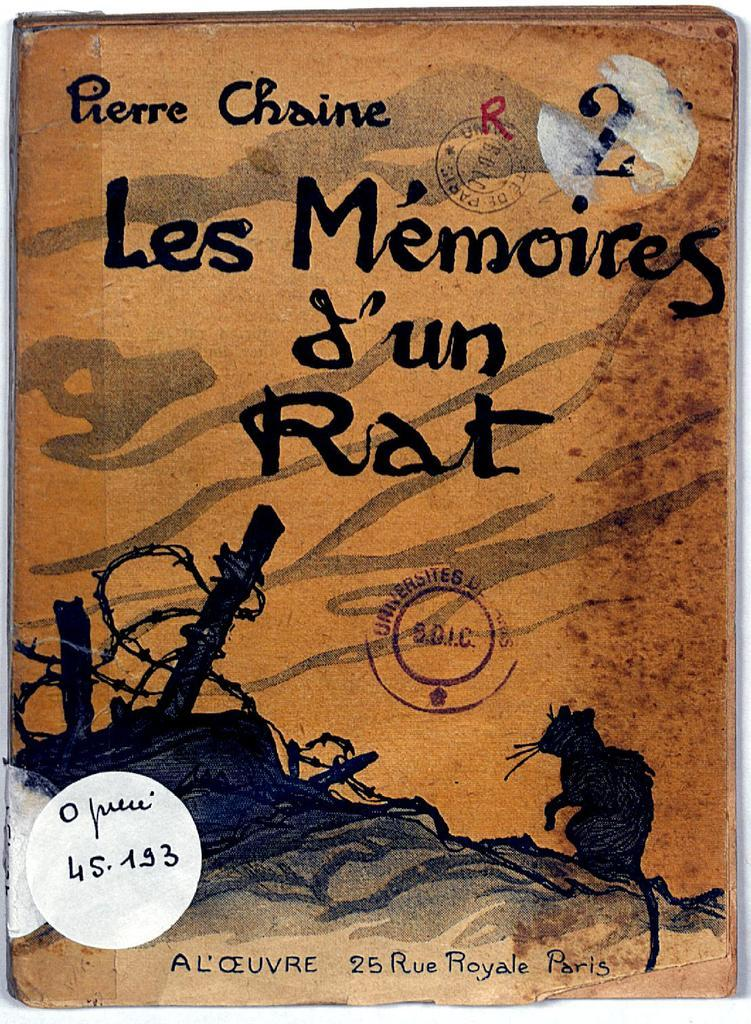<image>
Summarize the visual content of the image. The French novel Les Memoires D'un Rat by Pierre Chaine. 